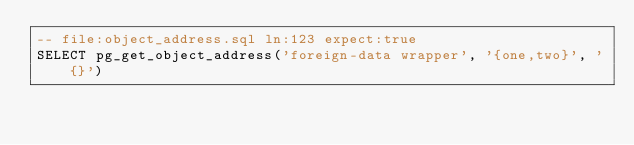Convert code to text. <code><loc_0><loc_0><loc_500><loc_500><_SQL_>-- file:object_address.sql ln:123 expect:true
SELECT pg_get_object_address('foreign-data wrapper', '{one,two}', '{}')
</code> 